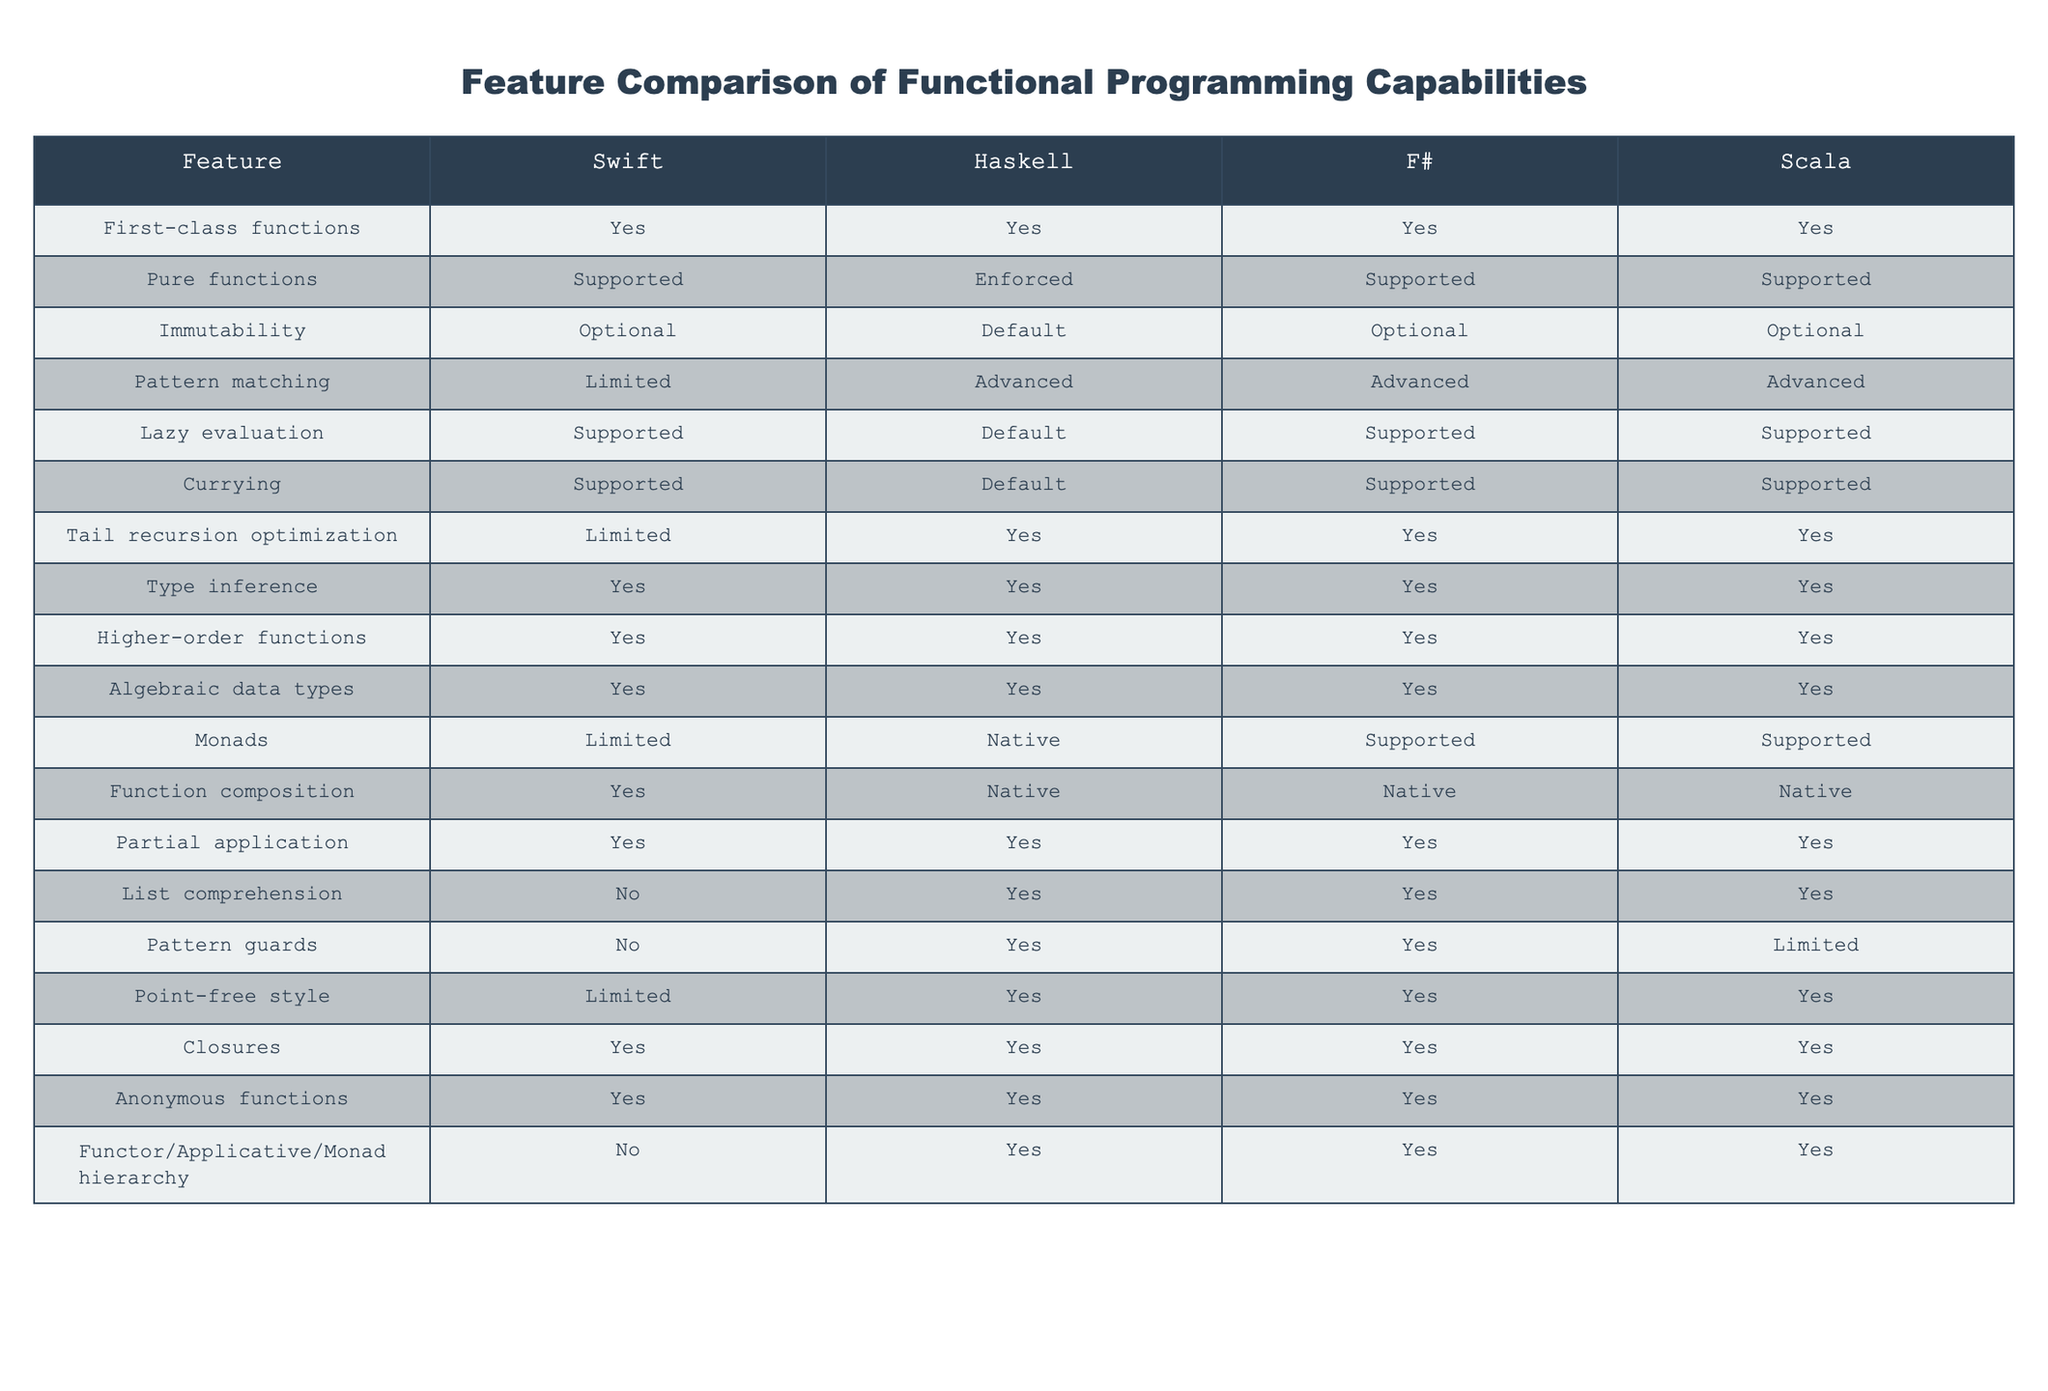What languages support first-class functions? By reviewing the table, we see that all four languages (Swift, Haskell, F#, and Scala) have first-class function support.
Answer: Swift, Haskell, F#, Scala Is pure function enforcement a feature in F#? According to the table, F# supports pure functions but does not enforce them. Thus, the feature is available but not a strict requirement.
Answer: No Which language has the most advanced pattern matching? The table explicitly states that Haskell, F#, and Scala have advanced pattern matching capabilities, while Swift has limited capabilities, indicating that Haskell, F#, and Scala are superior in this feature.
Answer: Haskell, F#, Scala Compare the support for monads between the languages. From the table, only Haskell has native support for monads, while Swift has limited support, and F# and Scala have supported monads, indicating varying levels of implementation across the languages.
Answer: Haskell (native), F# and Scala (supported), Swift (limited) How many languages support lazy evaluation? The table shows that four languages (Swift, Haskell, F#, and Scala) support lazy evaluation. Thus, all mentioned languages have this feature, indicating a significant capability in functional programming differentiation.
Answer: Four Which features do all languages have in common? By examining the table, we see that all four languages share features like first-class functions, higher-order functions, and algebraic data types. These features represent fundamental aspects of functional programming.
Answer: First-class functions, higher-order functions, algebraic data types Is it true that Swift has a default for immutability? The table indicates that Swift offers optional immutability, meaning it does not enforce immutability by default, unlike Haskell, which enforces it.
Answer: No If you wanted to use function composition, which languages could you choose? Reviewing the table, all four languages (Swift, Haskell, F#, and Scala) support function composition, allowing for flexibility in language choice for this feature.
Answer: Swift, Haskell, F#, Scala In terms of point-free style, how does Scala compare with Haskell? According to the table, Haskell supports point-free style, while Scala also allows it, indicating both languages have this feature. However, Haskell has limited points compared to Scala's broader applicability.
Answer: Both support it, but Haskell is limited 